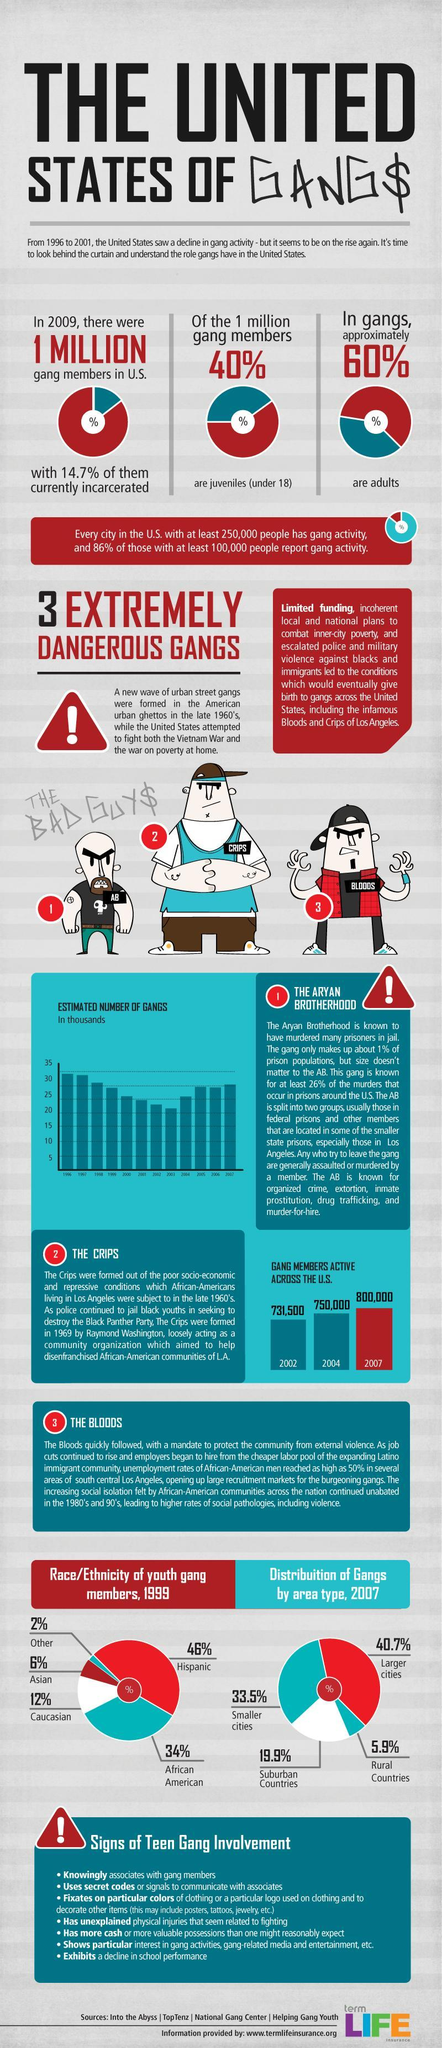Which area type has the least distribution of gangs?
Answer the question with a short phrase. Rural Countries What is total percentage distribution of gangs by area type? 100% What is race of youth gang members  belong to 2% category in the pie chart, Caucasian, Other or Asian? Other Calculate the total percentage of youth gang members in 1999 ? 100% Which is area has the second largest distribution of gangs? 33.5% Which has the second least youth gang members based on ethnicity ? Asian What is percentage difference in gang members between Hispanic and African American? 12% How many points come under the signs of teen gang involvement? 7 Calculate the increase in gang members in the US from 2002 until 2007 ? 68,500 